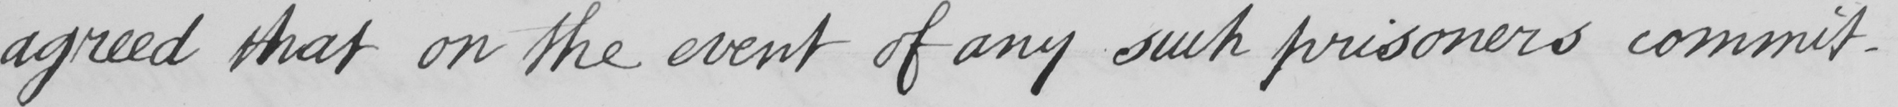Can you tell me what this handwritten text says? agreed that on the event of any such prisoners commit- 